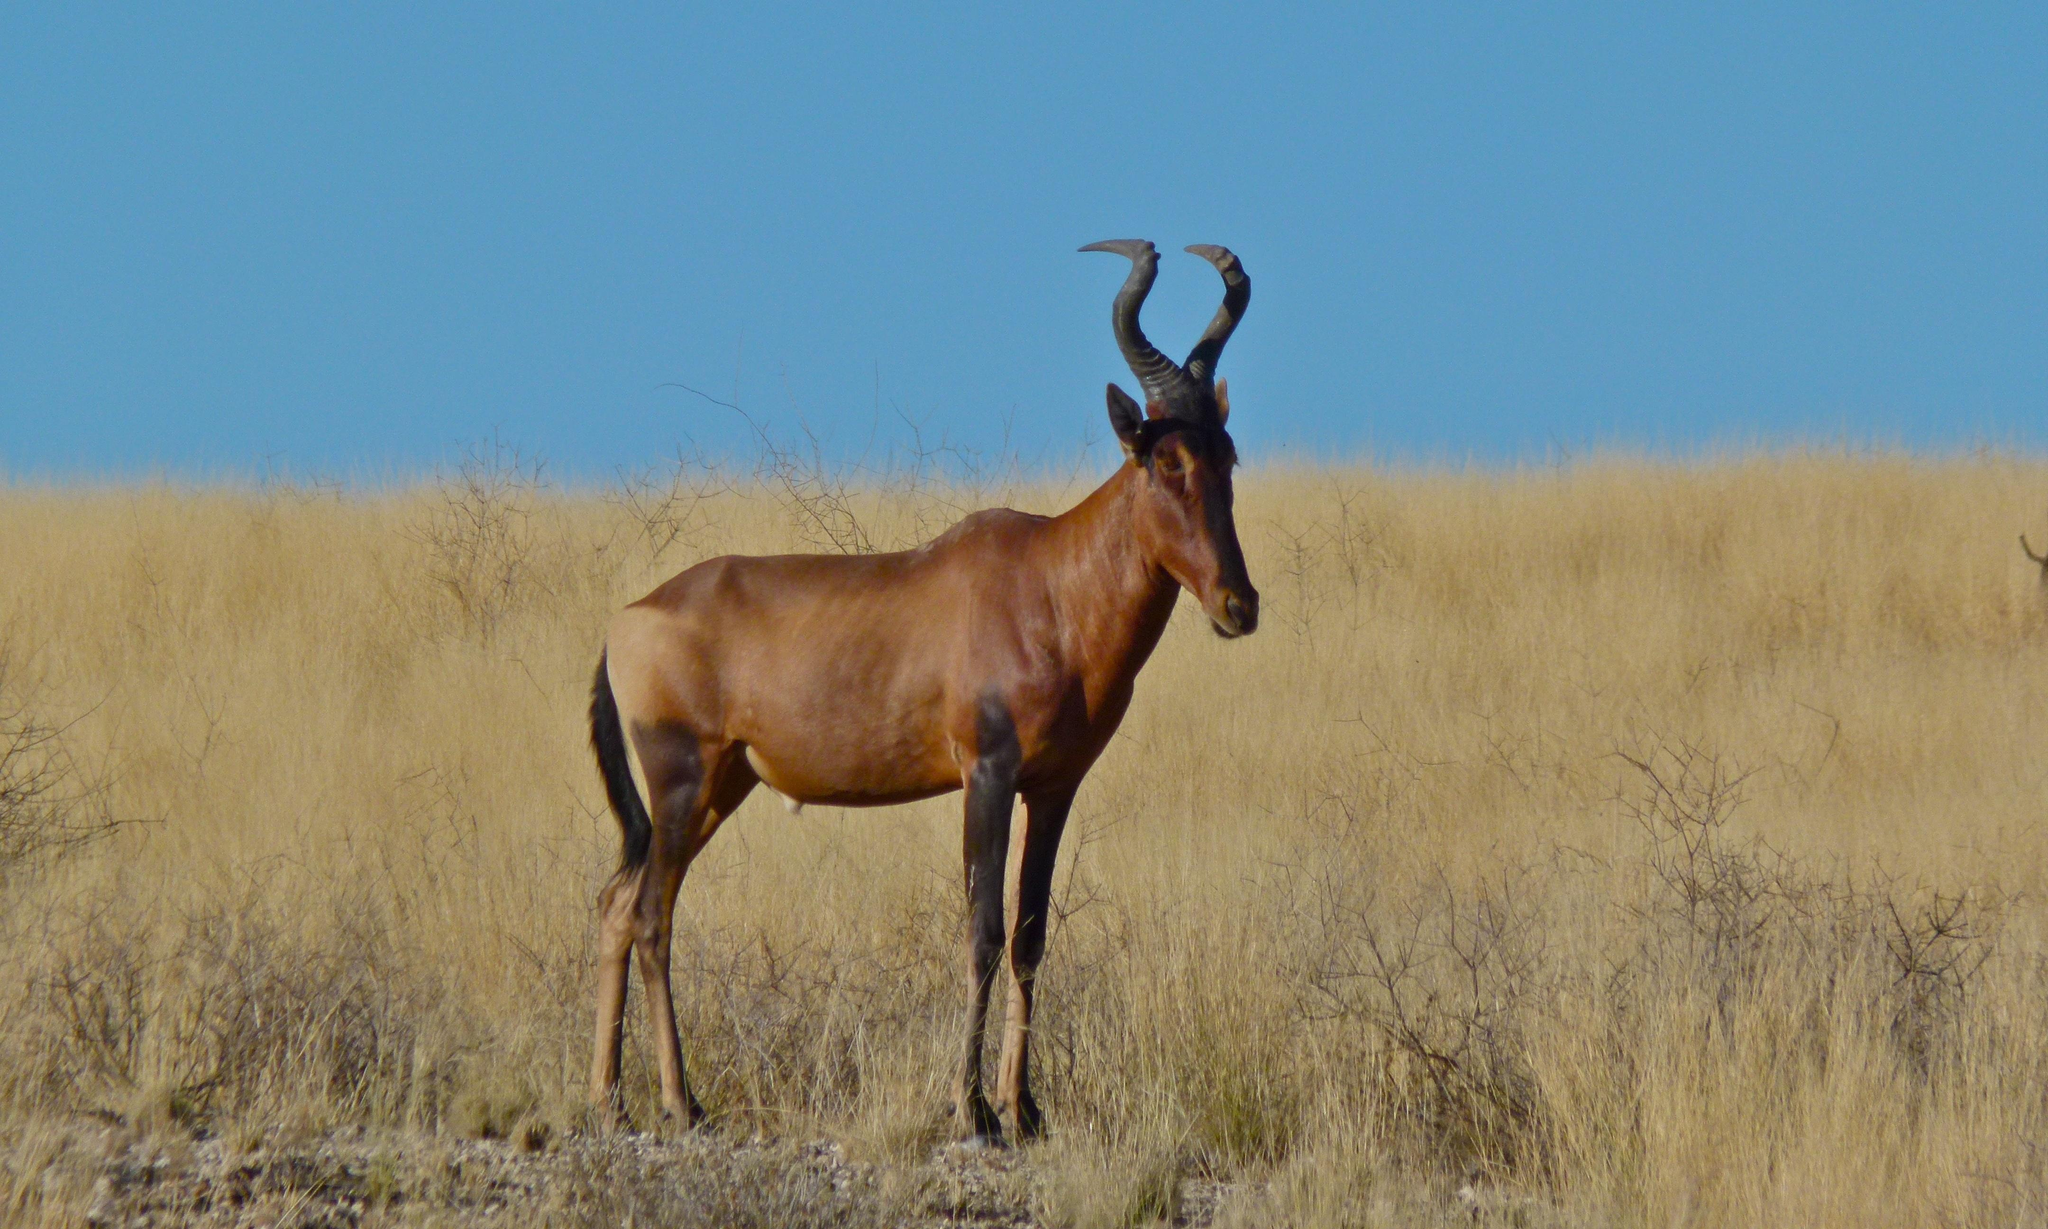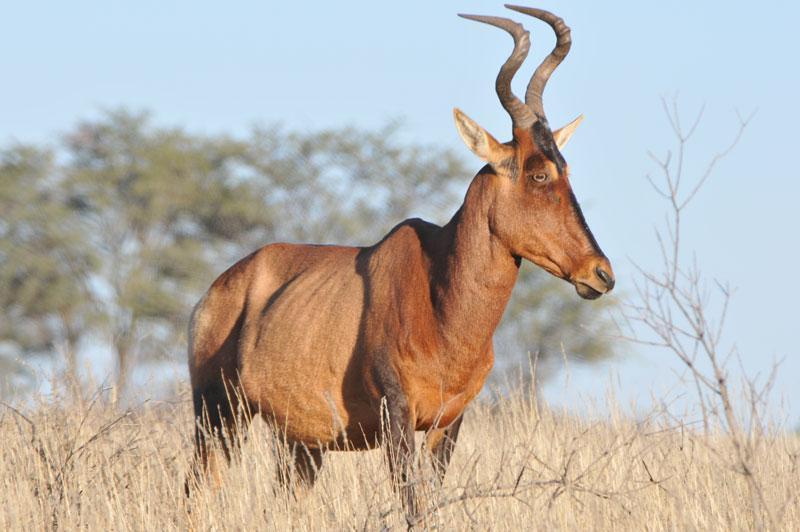The first image is the image on the left, the second image is the image on the right. Analyze the images presented: Is the assertion "Each image contains just one horned animal, and the animals in the right and left images face away from each other." valid? Answer yes or no. No. The first image is the image on the left, the second image is the image on the right. Analyze the images presented: Is the assertion "The image on the right contains a horned mammal looking to the right." valid? Answer yes or no. Yes. 